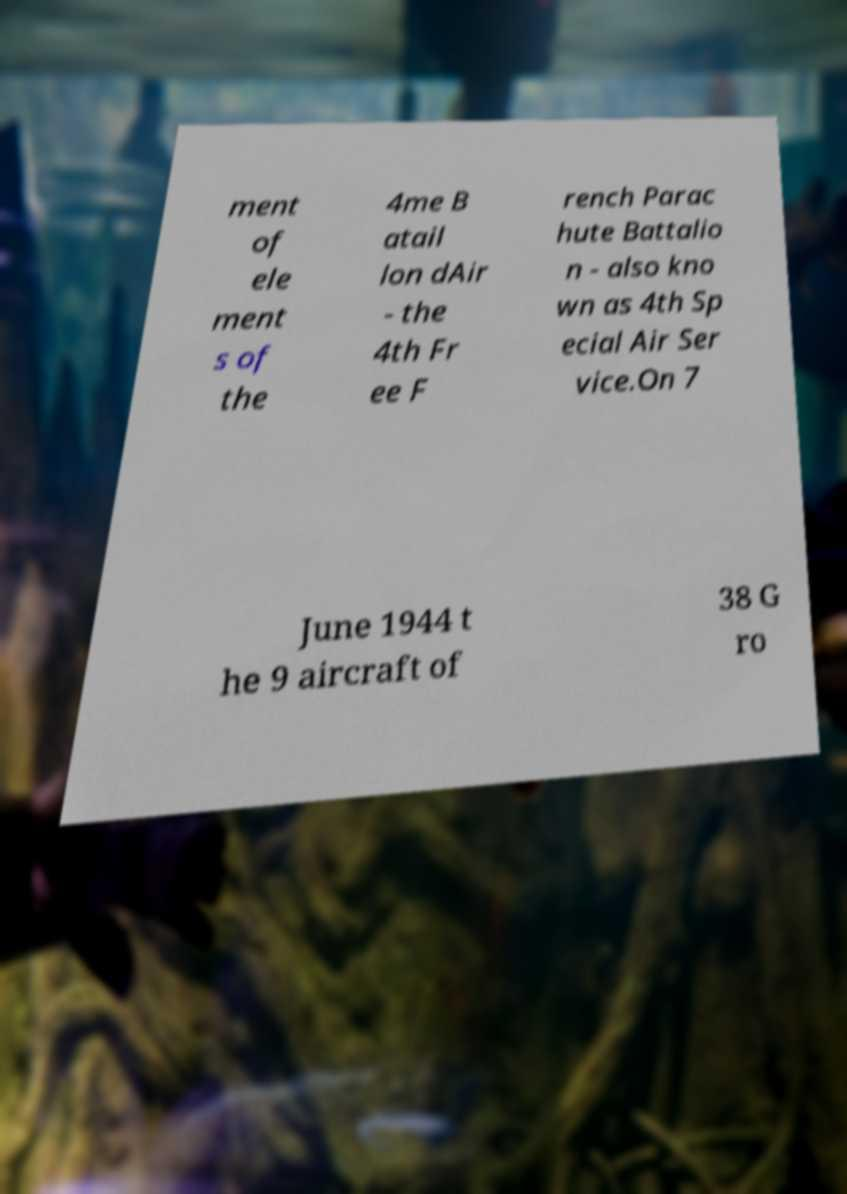I need the written content from this picture converted into text. Can you do that? ment of ele ment s of the 4me B atail lon dAir - the 4th Fr ee F rench Parac hute Battalio n - also kno wn as 4th Sp ecial Air Ser vice.On 7 June 1944 t he 9 aircraft of 38 G ro 